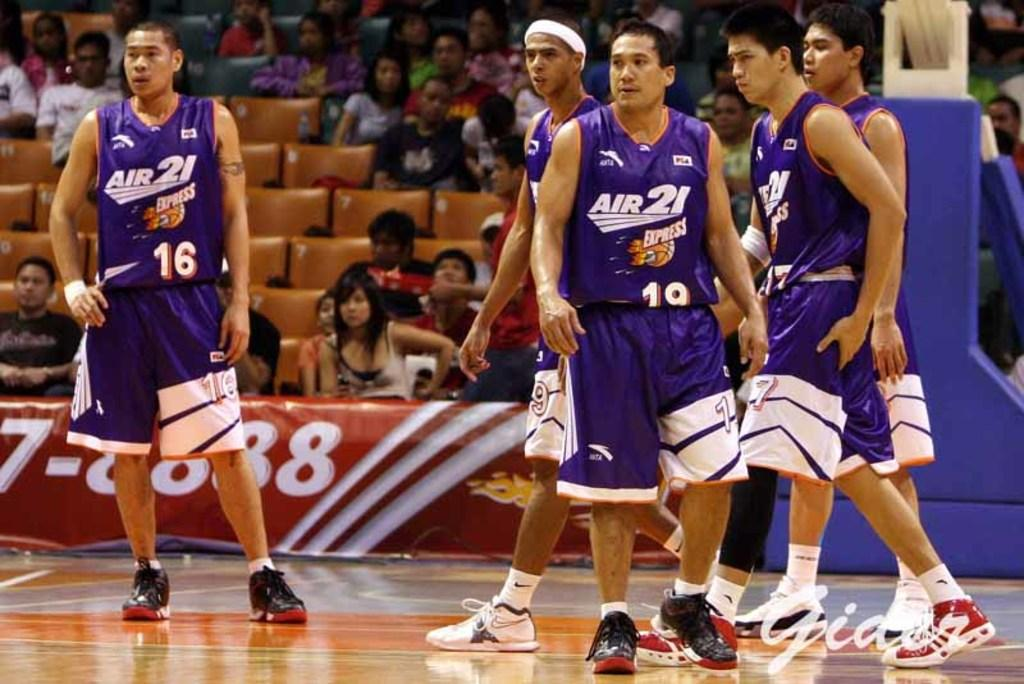<image>
Give a short and clear explanation of the subsequent image. The name of this basketball team is Air 21 Express. 